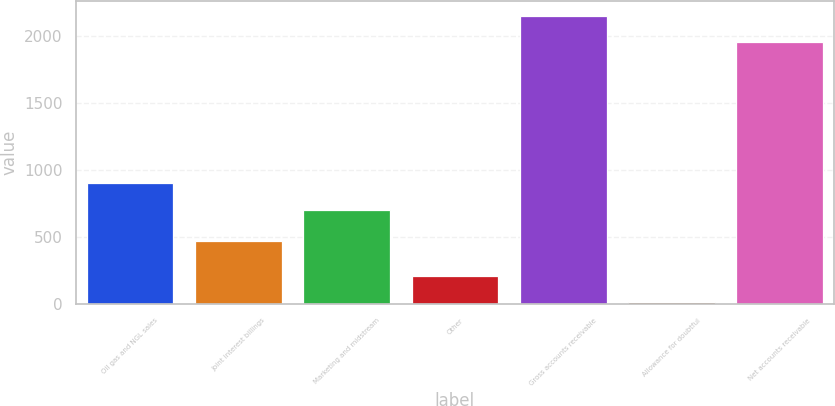Convert chart to OTSL. <chart><loc_0><loc_0><loc_500><loc_500><bar_chart><fcel>Oil gas and NGL sales<fcel>Joint interest billings<fcel>Marketing and midstream<fcel>Other<fcel>Gross accounts receivable<fcel>Allowance for doubtful<fcel>Net accounts receivable<nl><fcel>901.9<fcel>475<fcel>706<fcel>211.9<fcel>2154.9<fcel>16<fcel>1959<nl></chart> 